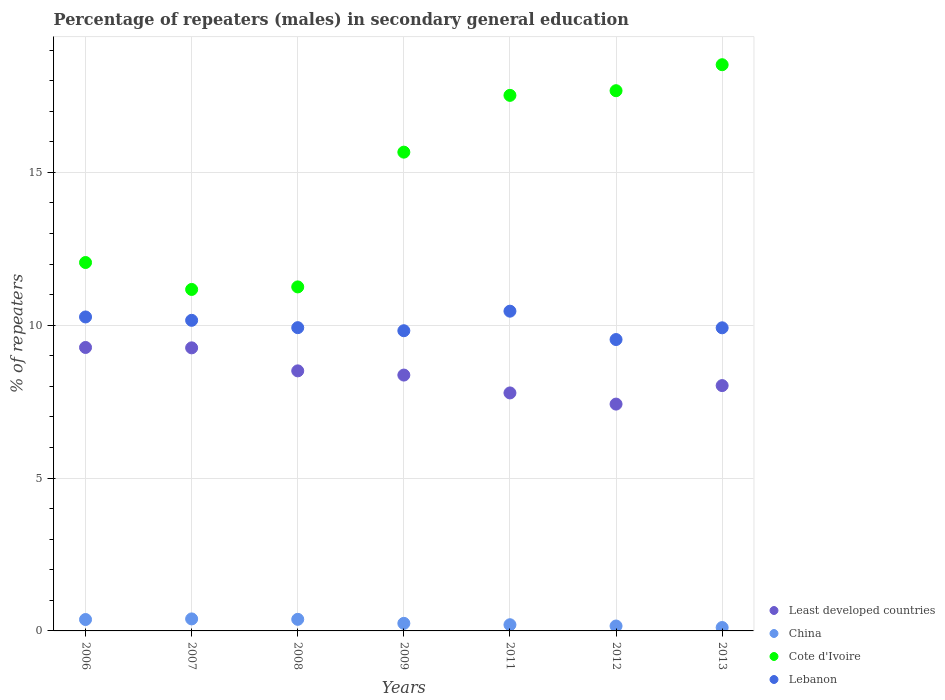What is the percentage of male repeaters in Least developed countries in 2006?
Give a very brief answer. 9.27. Across all years, what is the maximum percentage of male repeaters in Lebanon?
Give a very brief answer. 10.46. Across all years, what is the minimum percentage of male repeaters in China?
Make the answer very short. 0.11. In which year was the percentage of male repeaters in Lebanon maximum?
Keep it short and to the point. 2011. What is the total percentage of male repeaters in China in the graph?
Provide a short and direct response. 1.87. What is the difference between the percentage of male repeaters in Cote d'Ivoire in 2008 and that in 2013?
Provide a succinct answer. -7.27. What is the difference between the percentage of male repeaters in Lebanon in 2006 and the percentage of male repeaters in China in 2013?
Provide a succinct answer. 10.16. What is the average percentage of male repeaters in China per year?
Keep it short and to the point. 0.27. In the year 2011, what is the difference between the percentage of male repeaters in Lebanon and percentage of male repeaters in China?
Provide a short and direct response. 10.26. What is the ratio of the percentage of male repeaters in Cote d'Ivoire in 2008 to that in 2013?
Your answer should be very brief. 0.61. Is the difference between the percentage of male repeaters in Lebanon in 2009 and 2012 greater than the difference between the percentage of male repeaters in China in 2009 and 2012?
Give a very brief answer. Yes. What is the difference between the highest and the second highest percentage of male repeaters in Cote d'Ivoire?
Provide a succinct answer. 0.85. What is the difference between the highest and the lowest percentage of male repeaters in Lebanon?
Your response must be concise. 0.93. Is the sum of the percentage of male repeaters in Lebanon in 2008 and 2012 greater than the maximum percentage of male repeaters in Cote d'Ivoire across all years?
Your answer should be very brief. Yes. Does the percentage of male repeaters in Lebanon monotonically increase over the years?
Give a very brief answer. No. Is the percentage of male repeaters in Least developed countries strictly less than the percentage of male repeaters in Lebanon over the years?
Keep it short and to the point. Yes. How many dotlines are there?
Your answer should be very brief. 4. How many years are there in the graph?
Your response must be concise. 7. Does the graph contain any zero values?
Provide a succinct answer. No. Where does the legend appear in the graph?
Offer a terse response. Bottom right. How many legend labels are there?
Offer a terse response. 4. How are the legend labels stacked?
Give a very brief answer. Vertical. What is the title of the graph?
Ensure brevity in your answer.  Percentage of repeaters (males) in secondary general education. What is the label or title of the X-axis?
Make the answer very short. Years. What is the label or title of the Y-axis?
Your answer should be very brief. % of repeaters. What is the % of repeaters in Least developed countries in 2006?
Offer a very short reply. 9.27. What is the % of repeaters of China in 2006?
Your answer should be compact. 0.37. What is the % of repeaters of Cote d'Ivoire in 2006?
Give a very brief answer. 12.05. What is the % of repeaters in Lebanon in 2006?
Keep it short and to the point. 10.27. What is the % of repeaters in Least developed countries in 2007?
Provide a succinct answer. 9.26. What is the % of repeaters of China in 2007?
Ensure brevity in your answer.  0.39. What is the % of repeaters of Cote d'Ivoire in 2007?
Your answer should be very brief. 11.17. What is the % of repeaters in Lebanon in 2007?
Your response must be concise. 10.16. What is the % of repeaters of Least developed countries in 2008?
Provide a succinct answer. 8.51. What is the % of repeaters in China in 2008?
Your answer should be compact. 0.38. What is the % of repeaters of Cote d'Ivoire in 2008?
Your answer should be compact. 11.25. What is the % of repeaters in Lebanon in 2008?
Offer a very short reply. 9.92. What is the % of repeaters of Least developed countries in 2009?
Your answer should be compact. 8.37. What is the % of repeaters in China in 2009?
Offer a very short reply. 0.25. What is the % of repeaters in Cote d'Ivoire in 2009?
Give a very brief answer. 15.66. What is the % of repeaters of Lebanon in 2009?
Provide a succinct answer. 9.82. What is the % of repeaters in Least developed countries in 2011?
Your response must be concise. 7.78. What is the % of repeaters in China in 2011?
Keep it short and to the point. 0.2. What is the % of repeaters of Cote d'Ivoire in 2011?
Keep it short and to the point. 17.52. What is the % of repeaters of Lebanon in 2011?
Offer a very short reply. 10.46. What is the % of repeaters in Least developed countries in 2012?
Your answer should be compact. 7.42. What is the % of repeaters in China in 2012?
Provide a succinct answer. 0.16. What is the % of repeaters in Cote d'Ivoire in 2012?
Ensure brevity in your answer.  17.67. What is the % of repeaters in Lebanon in 2012?
Offer a terse response. 9.53. What is the % of repeaters of Least developed countries in 2013?
Make the answer very short. 8.02. What is the % of repeaters of China in 2013?
Give a very brief answer. 0.11. What is the % of repeaters in Cote d'Ivoire in 2013?
Offer a terse response. 18.52. What is the % of repeaters of Lebanon in 2013?
Offer a very short reply. 9.91. Across all years, what is the maximum % of repeaters of Least developed countries?
Ensure brevity in your answer.  9.27. Across all years, what is the maximum % of repeaters in China?
Your response must be concise. 0.39. Across all years, what is the maximum % of repeaters in Cote d'Ivoire?
Your answer should be very brief. 18.52. Across all years, what is the maximum % of repeaters in Lebanon?
Your answer should be very brief. 10.46. Across all years, what is the minimum % of repeaters of Least developed countries?
Your response must be concise. 7.42. Across all years, what is the minimum % of repeaters of China?
Provide a short and direct response. 0.11. Across all years, what is the minimum % of repeaters of Cote d'Ivoire?
Your response must be concise. 11.17. Across all years, what is the minimum % of repeaters of Lebanon?
Provide a short and direct response. 9.53. What is the total % of repeaters in Least developed countries in the graph?
Make the answer very short. 58.63. What is the total % of repeaters of China in the graph?
Ensure brevity in your answer.  1.87. What is the total % of repeaters in Cote d'Ivoire in the graph?
Your answer should be compact. 103.84. What is the total % of repeaters in Lebanon in the graph?
Provide a short and direct response. 70.07. What is the difference between the % of repeaters of Least developed countries in 2006 and that in 2007?
Ensure brevity in your answer.  0.01. What is the difference between the % of repeaters in China in 2006 and that in 2007?
Provide a succinct answer. -0.02. What is the difference between the % of repeaters of Cote d'Ivoire in 2006 and that in 2007?
Keep it short and to the point. 0.88. What is the difference between the % of repeaters in Lebanon in 2006 and that in 2007?
Keep it short and to the point. 0.11. What is the difference between the % of repeaters of Least developed countries in 2006 and that in 2008?
Offer a very short reply. 0.77. What is the difference between the % of repeaters of China in 2006 and that in 2008?
Your response must be concise. -0.01. What is the difference between the % of repeaters of Cote d'Ivoire in 2006 and that in 2008?
Your answer should be compact. 0.8. What is the difference between the % of repeaters of Lebanon in 2006 and that in 2008?
Your answer should be very brief. 0.35. What is the difference between the % of repeaters of Least developed countries in 2006 and that in 2009?
Your response must be concise. 0.9. What is the difference between the % of repeaters of China in 2006 and that in 2009?
Your response must be concise. 0.13. What is the difference between the % of repeaters in Cote d'Ivoire in 2006 and that in 2009?
Ensure brevity in your answer.  -3.61. What is the difference between the % of repeaters in Lebanon in 2006 and that in 2009?
Provide a short and direct response. 0.45. What is the difference between the % of repeaters of Least developed countries in 2006 and that in 2011?
Provide a short and direct response. 1.49. What is the difference between the % of repeaters in China in 2006 and that in 2011?
Give a very brief answer. 0.17. What is the difference between the % of repeaters in Cote d'Ivoire in 2006 and that in 2011?
Provide a short and direct response. -5.47. What is the difference between the % of repeaters of Lebanon in 2006 and that in 2011?
Ensure brevity in your answer.  -0.19. What is the difference between the % of repeaters in Least developed countries in 2006 and that in 2012?
Offer a terse response. 1.85. What is the difference between the % of repeaters of China in 2006 and that in 2012?
Provide a succinct answer. 0.21. What is the difference between the % of repeaters in Cote d'Ivoire in 2006 and that in 2012?
Provide a short and direct response. -5.62. What is the difference between the % of repeaters in Lebanon in 2006 and that in 2012?
Provide a short and direct response. 0.74. What is the difference between the % of repeaters in Least developed countries in 2006 and that in 2013?
Provide a succinct answer. 1.25. What is the difference between the % of repeaters in China in 2006 and that in 2013?
Offer a terse response. 0.26. What is the difference between the % of repeaters of Cote d'Ivoire in 2006 and that in 2013?
Your answer should be very brief. -6.47. What is the difference between the % of repeaters in Lebanon in 2006 and that in 2013?
Keep it short and to the point. 0.35. What is the difference between the % of repeaters of Least developed countries in 2007 and that in 2008?
Make the answer very short. 0.75. What is the difference between the % of repeaters of China in 2007 and that in 2008?
Provide a short and direct response. 0.01. What is the difference between the % of repeaters in Cote d'Ivoire in 2007 and that in 2008?
Offer a very short reply. -0.08. What is the difference between the % of repeaters of Lebanon in 2007 and that in 2008?
Your response must be concise. 0.24. What is the difference between the % of repeaters of Least developed countries in 2007 and that in 2009?
Your response must be concise. 0.89. What is the difference between the % of repeaters of China in 2007 and that in 2009?
Your answer should be very brief. 0.14. What is the difference between the % of repeaters of Cote d'Ivoire in 2007 and that in 2009?
Ensure brevity in your answer.  -4.49. What is the difference between the % of repeaters in Lebanon in 2007 and that in 2009?
Offer a terse response. 0.34. What is the difference between the % of repeaters of Least developed countries in 2007 and that in 2011?
Provide a succinct answer. 1.47. What is the difference between the % of repeaters in China in 2007 and that in 2011?
Your answer should be very brief. 0.19. What is the difference between the % of repeaters of Cote d'Ivoire in 2007 and that in 2011?
Provide a succinct answer. -6.35. What is the difference between the % of repeaters in Lebanon in 2007 and that in 2011?
Offer a terse response. -0.3. What is the difference between the % of repeaters of Least developed countries in 2007 and that in 2012?
Keep it short and to the point. 1.84. What is the difference between the % of repeaters of China in 2007 and that in 2012?
Your answer should be very brief. 0.23. What is the difference between the % of repeaters of Cote d'Ivoire in 2007 and that in 2012?
Offer a terse response. -6.5. What is the difference between the % of repeaters of Lebanon in 2007 and that in 2012?
Offer a very short reply. 0.63. What is the difference between the % of repeaters of Least developed countries in 2007 and that in 2013?
Your answer should be compact. 1.23. What is the difference between the % of repeaters in China in 2007 and that in 2013?
Keep it short and to the point. 0.28. What is the difference between the % of repeaters in Cote d'Ivoire in 2007 and that in 2013?
Provide a succinct answer. -7.35. What is the difference between the % of repeaters in Lebanon in 2007 and that in 2013?
Make the answer very short. 0.24. What is the difference between the % of repeaters of Least developed countries in 2008 and that in 2009?
Your answer should be very brief. 0.14. What is the difference between the % of repeaters of China in 2008 and that in 2009?
Provide a short and direct response. 0.13. What is the difference between the % of repeaters of Cote d'Ivoire in 2008 and that in 2009?
Keep it short and to the point. -4.41. What is the difference between the % of repeaters of Lebanon in 2008 and that in 2009?
Your answer should be compact. 0.1. What is the difference between the % of repeaters in Least developed countries in 2008 and that in 2011?
Provide a succinct answer. 0.72. What is the difference between the % of repeaters of China in 2008 and that in 2011?
Your answer should be very brief. 0.18. What is the difference between the % of repeaters of Cote d'Ivoire in 2008 and that in 2011?
Provide a short and direct response. -6.27. What is the difference between the % of repeaters in Lebanon in 2008 and that in 2011?
Offer a terse response. -0.54. What is the difference between the % of repeaters in Least developed countries in 2008 and that in 2012?
Offer a very short reply. 1.09. What is the difference between the % of repeaters of China in 2008 and that in 2012?
Give a very brief answer. 0.22. What is the difference between the % of repeaters in Cote d'Ivoire in 2008 and that in 2012?
Provide a succinct answer. -6.42. What is the difference between the % of repeaters of Lebanon in 2008 and that in 2012?
Ensure brevity in your answer.  0.39. What is the difference between the % of repeaters in Least developed countries in 2008 and that in 2013?
Your response must be concise. 0.48. What is the difference between the % of repeaters in China in 2008 and that in 2013?
Ensure brevity in your answer.  0.27. What is the difference between the % of repeaters of Cote d'Ivoire in 2008 and that in 2013?
Offer a very short reply. -7.27. What is the difference between the % of repeaters of Lebanon in 2008 and that in 2013?
Ensure brevity in your answer.  0. What is the difference between the % of repeaters in Least developed countries in 2009 and that in 2011?
Give a very brief answer. 0.58. What is the difference between the % of repeaters of China in 2009 and that in 2011?
Provide a succinct answer. 0.05. What is the difference between the % of repeaters of Cote d'Ivoire in 2009 and that in 2011?
Keep it short and to the point. -1.86. What is the difference between the % of repeaters of Lebanon in 2009 and that in 2011?
Offer a very short reply. -0.64. What is the difference between the % of repeaters of Least developed countries in 2009 and that in 2012?
Your response must be concise. 0.95. What is the difference between the % of repeaters of China in 2009 and that in 2012?
Your response must be concise. 0.09. What is the difference between the % of repeaters in Cote d'Ivoire in 2009 and that in 2012?
Ensure brevity in your answer.  -2.01. What is the difference between the % of repeaters of Lebanon in 2009 and that in 2012?
Ensure brevity in your answer.  0.29. What is the difference between the % of repeaters of Least developed countries in 2009 and that in 2013?
Your answer should be very brief. 0.34. What is the difference between the % of repeaters of China in 2009 and that in 2013?
Your response must be concise. 0.14. What is the difference between the % of repeaters of Cote d'Ivoire in 2009 and that in 2013?
Keep it short and to the point. -2.86. What is the difference between the % of repeaters of Lebanon in 2009 and that in 2013?
Provide a succinct answer. -0.1. What is the difference between the % of repeaters in Least developed countries in 2011 and that in 2012?
Your response must be concise. 0.37. What is the difference between the % of repeaters of China in 2011 and that in 2012?
Your answer should be very brief. 0.04. What is the difference between the % of repeaters of Cote d'Ivoire in 2011 and that in 2012?
Provide a short and direct response. -0.15. What is the difference between the % of repeaters in Lebanon in 2011 and that in 2012?
Give a very brief answer. 0.93. What is the difference between the % of repeaters in Least developed countries in 2011 and that in 2013?
Your response must be concise. -0.24. What is the difference between the % of repeaters in China in 2011 and that in 2013?
Your answer should be compact. 0.09. What is the difference between the % of repeaters in Cote d'Ivoire in 2011 and that in 2013?
Your answer should be very brief. -1. What is the difference between the % of repeaters of Lebanon in 2011 and that in 2013?
Offer a very short reply. 0.54. What is the difference between the % of repeaters in Least developed countries in 2012 and that in 2013?
Offer a terse response. -0.61. What is the difference between the % of repeaters in China in 2012 and that in 2013?
Offer a terse response. 0.05. What is the difference between the % of repeaters in Cote d'Ivoire in 2012 and that in 2013?
Make the answer very short. -0.85. What is the difference between the % of repeaters in Lebanon in 2012 and that in 2013?
Offer a terse response. -0.38. What is the difference between the % of repeaters in Least developed countries in 2006 and the % of repeaters in China in 2007?
Offer a terse response. 8.88. What is the difference between the % of repeaters of Least developed countries in 2006 and the % of repeaters of Cote d'Ivoire in 2007?
Your response must be concise. -1.9. What is the difference between the % of repeaters of Least developed countries in 2006 and the % of repeaters of Lebanon in 2007?
Offer a terse response. -0.89. What is the difference between the % of repeaters in China in 2006 and the % of repeaters in Cote d'Ivoire in 2007?
Offer a terse response. -10.8. What is the difference between the % of repeaters in China in 2006 and the % of repeaters in Lebanon in 2007?
Your answer should be very brief. -9.79. What is the difference between the % of repeaters of Cote d'Ivoire in 2006 and the % of repeaters of Lebanon in 2007?
Give a very brief answer. 1.89. What is the difference between the % of repeaters in Least developed countries in 2006 and the % of repeaters in China in 2008?
Keep it short and to the point. 8.89. What is the difference between the % of repeaters in Least developed countries in 2006 and the % of repeaters in Cote d'Ivoire in 2008?
Make the answer very short. -1.98. What is the difference between the % of repeaters in Least developed countries in 2006 and the % of repeaters in Lebanon in 2008?
Give a very brief answer. -0.65. What is the difference between the % of repeaters in China in 2006 and the % of repeaters in Cote d'Ivoire in 2008?
Offer a very short reply. -10.88. What is the difference between the % of repeaters of China in 2006 and the % of repeaters of Lebanon in 2008?
Keep it short and to the point. -9.55. What is the difference between the % of repeaters of Cote d'Ivoire in 2006 and the % of repeaters of Lebanon in 2008?
Offer a terse response. 2.13. What is the difference between the % of repeaters in Least developed countries in 2006 and the % of repeaters in China in 2009?
Your answer should be compact. 9.02. What is the difference between the % of repeaters in Least developed countries in 2006 and the % of repeaters in Cote d'Ivoire in 2009?
Provide a short and direct response. -6.39. What is the difference between the % of repeaters of Least developed countries in 2006 and the % of repeaters of Lebanon in 2009?
Your answer should be compact. -0.55. What is the difference between the % of repeaters in China in 2006 and the % of repeaters in Cote d'Ivoire in 2009?
Ensure brevity in your answer.  -15.29. What is the difference between the % of repeaters of China in 2006 and the % of repeaters of Lebanon in 2009?
Keep it short and to the point. -9.45. What is the difference between the % of repeaters of Cote d'Ivoire in 2006 and the % of repeaters of Lebanon in 2009?
Give a very brief answer. 2.23. What is the difference between the % of repeaters of Least developed countries in 2006 and the % of repeaters of China in 2011?
Make the answer very short. 9.07. What is the difference between the % of repeaters in Least developed countries in 2006 and the % of repeaters in Cote d'Ivoire in 2011?
Make the answer very short. -8.25. What is the difference between the % of repeaters of Least developed countries in 2006 and the % of repeaters of Lebanon in 2011?
Provide a short and direct response. -1.19. What is the difference between the % of repeaters in China in 2006 and the % of repeaters in Cote d'Ivoire in 2011?
Your response must be concise. -17.14. What is the difference between the % of repeaters in China in 2006 and the % of repeaters in Lebanon in 2011?
Offer a very short reply. -10.09. What is the difference between the % of repeaters in Cote d'Ivoire in 2006 and the % of repeaters in Lebanon in 2011?
Provide a short and direct response. 1.59. What is the difference between the % of repeaters of Least developed countries in 2006 and the % of repeaters of China in 2012?
Provide a succinct answer. 9.11. What is the difference between the % of repeaters of Least developed countries in 2006 and the % of repeaters of Cote d'Ivoire in 2012?
Ensure brevity in your answer.  -8.4. What is the difference between the % of repeaters of Least developed countries in 2006 and the % of repeaters of Lebanon in 2012?
Offer a very short reply. -0.26. What is the difference between the % of repeaters of China in 2006 and the % of repeaters of Cote d'Ivoire in 2012?
Your answer should be very brief. -17.3. What is the difference between the % of repeaters in China in 2006 and the % of repeaters in Lebanon in 2012?
Ensure brevity in your answer.  -9.16. What is the difference between the % of repeaters of Cote d'Ivoire in 2006 and the % of repeaters of Lebanon in 2012?
Your answer should be very brief. 2.52. What is the difference between the % of repeaters in Least developed countries in 2006 and the % of repeaters in China in 2013?
Offer a terse response. 9.16. What is the difference between the % of repeaters in Least developed countries in 2006 and the % of repeaters in Cote d'Ivoire in 2013?
Make the answer very short. -9.25. What is the difference between the % of repeaters in Least developed countries in 2006 and the % of repeaters in Lebanon in 2013?
Provide a short and direct response. -0.64. What is the difference between the % of repeaters in China in 2006 and the % of repeaters in Cote d'Ivoire in 2013?
Offer a very short reply. -18.15. What is the difference between the % of repeaters in China in 2006 and the % of repeaters in Lebanon in 2013?
Provide a succinct answer. -9.54. What is the difference between the % of repeaters of Cote d'Ivoire in 2006 and the % of repeaters of Lebanon in 2013?
Your answer should be very brief. 2.14. What is the difference between the % of repeaters of Least developed countries in 2007 and the % of repeaters of China in 2008?
Provide a succinct answer. 8.88. What is the difference between the % of repeaters in Least developed countries in 2007 and the % of repeaters in Cote d'Ivoire in 2008?
Your response must be concise. -1.99. What is the difference between the % of repeaters of Least developed countries in 2007 and the % of repeaters of Lebanon in 2008?
Ensure brevity in your answer.  -0.66. What is the difference between the % of repeaters in China in 2007 and the % of repeaters in Cote d'Ivoire in 2008?
Offer a very short reply. -10.86. What is the difference between the % of repeaters of China in 2007 and the % of repeaters of Lebanon in 2008?
Keep it short and to the point. -9.53. What is the difference between the % of repeaters of Cote d'Ivoire in 2007 and the % of repeaters of Lebanon in 2008?
Your answer should be very brief. 1.25. What is the difference between the % of repeaters of Least developed countries in 2007 and the % of repeaters of China in 2009?
Your answer should be very brief. 9.01. What is the difference between the % of repeaters of Least developed countries in 2007 and the % of repeaters of Cote d'Ivoire in 2009?
Your answer should be compact. -6.4. What is the difference between the % of repeaters of Least developed countries in 2007 and the % of repeaters of Lebanon in 2009?
Your answer should be compact. -0.56. What is the difference between the % of repeaters of China in 2007 and the % of repeaters of Cote d'Ivoire in 2009?
Your response must be concise. -15.27. What is the difference between the % of repeaters in China in 2007 and the % of repeaters in Lebanon in 2009?
Your answer should be compact. -9.43. What is the difference between the % of repeaters of Cote d'Ivoire in 2007 and the % of repeaters of Lebanon in 2009?
Keep it short and to the point. 1.35. What is the difference between the % of repeaters in Least developed countries in 2007 and the % of repeaters in China in 2011?
Give a very brief answer. 9.06. What is the difference between the % of repeaters in Least developed countries in 2007 and the % of repeaters in Cote d'Ivoire in 2011?
Keep it short and to the point. -8.26. What is the difference between the % of repeaters of Least developed countries in 2007 and the % of repeaters of Lebanon in 2011?
Ensure brevity in your answer.  -1.2. What is the difference between the % of repeaters of China in 2007 and the % of repeaters of Cote d'Ivoire in 2011?
Give a very brief answer. -17.12. What is the difference between the % of repeaters of China in 2007 and the % of repeaters of Lebanon in 2011?
Keep it short and to the point. -10.07. What is the difference between the % of repeaters in Cote d'Ivoire in 2007 and the % of repeaters in Lebanon in 2011?
Ensure brevity in your answer.  0.71. What is the difference between the % of repeaters of Least developed countries in 2007 and the % of repeaters of China in 2012?
Ensure brevity in your answer.  9.1. What is the difference between the % of repeaters in Least developed countries in 2007 and the % of repeaters in Cote d'Ivoire in 2012?
Your answer should be very brief. -8.41. What is the difference between the % of repeaters of Least developed countries in 2007 and the % of repeaters of Lebanon in 2012?
Offer a terse response. -0.27. What is the difference between the % of repeaters of China in 2007 and the % of repeaters of Cote d'Ivoire in 2012?
Your answer should be very brief. -17.28. What is the difference between the % of repeaters in China in 2007 and the % of repeaters in Lebanon in 2012?
Provide a short and direct response. -9.14. What is the difference between the % of repeaters in Cote d'Ivoire in 2007 and the % of repeaters in Lebanon in 2012?
Ensure brevity in your answer.  1.64. What is the difference between the % of repeaters in Least developed countries in 2007 and the % of repeaters in China in 2013?
Give a very brief answer. 9.15. What is the difference between the % of repeaters in Least developed countries in 2007 and the % of repeaters in Cote d'Ivoire in 2013?
Offer a terse response. -9.26. What is the difference between the % of repeaters of Least developed countries in 2007 and the % of repeaters of Lebanon in 2013?
Offer a very short reply. -0.66. What is the difference between the % of repeaters in China in 2007 and the % of repeaters in Cote d'Ivoire in 2013?
Your answer should be compact. -18.13. What is the difference between the % of repeaters in China in 2007 and the % of repeaters in Lebanon in 2013?
Provide a short and direct response. -9.52. What is the difference between the % of repeaters in Cote d'Ivoire in 2007 and the % of repeaters in Lebanon in 2013?
Provide a short and direct response. 1.25. What is the difference between the % of repeaters in Least developed countries in 2008 and the % of repeaters in China in 2009?
Your answer should be compact. 8.26. What is the difference between the % of repeaters in Least developed countries in 2008 and the % of repeaters in Cote d'Ivoire in 2009?
Your answer should be very brief. -7.15. What is the difference between the % of repeaters in Least developed countries in 2008 and the % of repeaters in Lebanon in 2009?
Keep it short and to the point. -1.31. What is the difference between the % of repeaters in China in 2008 and the % of repeaters in Cote d'Ivoire in 2009?
Provide a short and direct response. -15.28. What is the difference between the % of repeaters in China in 2008 and the % of repeaters in Lebanon in 2009?
Provide a succinct answer. -9.44. What is the difference between the % of repeaters in Cote d'Ivoire in 2008 and the % of repeaters in Lebanon in 2009?
Provide a short and direct response. 1.43. What is the difference between the % of repeaters of Least developed countries in 2008 and the % of repeaters of China in 2011?
Provide a succinct answer. 8.3. What is the difference between the % of repeaters in Least developed countries in 2008 and the % of repeaters in Cote d'Ivoire in 2011?
Keep it short and to the point. -9.01. What is the difference between the % of repeaters of Least developed countries in 2008 and the % of repeaters of Lebanon in 2011?
Offer a very short reply. -1.95. What is the difference between the % of repeaters in China in 2008 and the % of repeaters in Cote d'Ivoire in 2011?
Give a very brief answer. -17.14. What is the difference between the % of repeaters in China in 2008 and the % of repeaters in Lebanon in 2011?
Give a very brief answer. -10.08. What is the difference between the % of repeaters of Cote d'Ivoire in 2008 and the % of repeaters of Lebanon in 2011?
Your answer should be compact. 0.79. What is the difference between the % of repeaters of Least developed countries in 2008 and the % of repeaters of China in 2012?
Provide a short and direct response. 8.35. What is the difference between the % of repeaters in Least developed countries in 2008 and the % of repeaters in Cote d'Ivoire in 2012?
Keep it short and to the point. -9.16. What is the difference between the % of repeaters in Least developed countries in 2008 and the % of repeaters in Lebanon in 2012?
Keep it short and to the point. -1.02. What is the difference between the % of repeaters of China in 2008 and the % of repeaters of Cote d'Ivoire in 2012?
Give a very brief answer. -17.29. What is the difference between the % of repeaters of China in 2008 and the % of repeaters of Lebanon in 2012?
Your response must be concise. -9.15. What is the difference between the % of repeaters of Cote d'Ivoire in 2008 and the % of repeaters of Lebanon in 2012?
Make the answer very short. 1.72. What is the difference between the % of repeaters of Least developed countries in 2008 and the % of repeaters of China in 2013?
Your response must be concise. 8.4. What is the difference between the % of repeaters in Least developed countries in 2008 and the % of repeaters in Cote d'Ivoire in 2013?
Your answer should be very brief. -10.01. What is the difference between the % of repeaters in Least developed countries in 2008 and the % of repeaters in Lebanon in 2013?
Offer a very short reply. -1.41. What is the difference between the % of repeaters of China in 2008 and the % of repeaters of Cote d'Ivoire in 2013?
Provide a short and direct response. -18.14. What is the difference between the % of repeaters of China in 2008 and the % of repeaters of Lebanon in 2013?
Your answer should be compact. -9.54. What is the difference between the % of repeaters of Cote d'Ivoire in 2008 and the % of repeaters of Lebanon in 2013?
Provide a succinct answer. 1.34. What is the difference between the % of repeaters in Least developed countries in 2009 and the % of repeaters in China in 2011?
Keep it short and to the point. 8.17. What is the difference between the % of repeaters of Least developed countries in 2009 and the % of repeaters of Cote d'Ivoire in 2011?
Your response must be concise. -9.15. What is the difference between the % of repeaters of Least developed countries in 2009 and the % of repeaters of Lebanon in 2011?
Provide a short and direct response. -2.09. What is the difference between the % of repeaters of China in 2009 and the % of repeaters of Cote d'Ivoire in 2011?
Keep it short and to the point. -17.27. What is the difference between the % of repeaters in China in 2009 and the % of repeaters in Lebanon in 2011?
Offer a terse response. -10.21. What is the difference between the % of repeaters of Cote d'Ivoire in 2009 and the % of repeaters of Lebanon in 2011?
Give a very brief answer. 5.2. What is the difference between the % of repeaters in Least developed countries in 2009 and the % of repeaters in China in 2012?
Give a very brief answer. 8.21. What is the difference between the % of repeaters in Least developed countries in 2009 and the % of repeaters in Cote d'Ivoire in 2012?
Your answer should be very brief. -9.3. What is the difference between the % of repeaters in Least developed countries in 2009 and the % of repeaters in Lebanon in 2012?
Your answer should be very brief. -1.16. What is the difference between the % of repeaters in China in 2009 and the % of repeaters in Cote d'Ivoire in 2012?
Provide a succinct answer. -17.42. What is the difference between the % of repeaters of China in 2009 and the % of repeaters of Lebanon in 2012?
Provide a succinct answer. -9.28. What is the difference between the % of repeaters in Cote d'Ivoire in 2009 and the % of repeaters in Lebanon in 2012?
Your response must be concise. 6.13. What is the difference between the % of repeaters in Least developed countries in 2009 and the % of repeaters in China in 2013?
Provide a succinct answer. 8.26. What is the difference between the % of repeaters in Least developed countries in 2009 and the % of repeaters in Cote d'Ivoire in 2013?
Offer a terse response. -10.15. What is the difference between the % of repeaters in Least developed countries in 2009 and the % of repeaters in Lebanon in 2013?
Your answer should be very brief. -1.55. What is the difference between the % of repeaters of China in 2009 and the % of repeaters of Cote d'Ivoire in 2013?
Your answer should be very brief. -18.27. What is the difference between the % of repeaters in China in 2009 and the % of repeaters in Lebanon in 2013?
Your answer should be compact. -9.67. What is the difference between the % of repeaters in Cote d'Ivoire in 2009 and the % of repeaters in Lebanon in 2013?
Offer a very short reply. 5.75. What is the difference between the % of repeaters in Least developed countries in 2011 and the % of repeaters in China in 2012?
Offer a very short reply. 7.62. What is the difference between the % of repeaters in Least developed countries in 2011 and the % of repeaters in Cote d'Ivoire in 2012?
Make the answer very short. -9.89. What is the difference between the % of repeaters in Least developed countries in 2011 and the % of repeaters in Lebanon in 2012?
Your answer should be very brief. -1.75. What is the difference between the % of repeaters of China in 2011 and the % of repeaters of Cote d'Ivoire in 2012?
Your response must be concise. -17.47. What is the difference between the % of repeaters of China in 2011 and the % of repeaters of Lebanon in 2012?
Ensure brevity in your answer.  -9.33. What is the difference between the % of repeaters of Cote d'Ivoire in 2011 and the % of repeaters of Lebanon in 2012?
Ensure brevity in your answer.  7.99. What is the difference between the % of repeaters in Least developed countries in 2011 and the % of repeaters in China in 2013?
Give a very brief answer. 7.67. What is the difference between the % of repeaters of Least developed countries in 2011 and the % of repeaters of Cote d'Ivoire in 2013?
Ensure brevity in your answer.  -10.74. What is the difference between the % of repeaters in Least developed countries in 2011 and the % of repeaters in Lebanon in 2013?
Provide a succinct answer. -2.13. What is the difference between the % of repeaters of China in 2011 and the % of repeaters of Cote d'Ivoire in 2013?
Keep it short and to the point. -18.32. What is the difference between the % of repeaters of China in 2011 and the % of repeaters of Lebanon in 2013?
Offer a very short reply. -9.71. What is the difference between the % of repeaters of Cote d'Ivoire in 2011 and the % of repeaters of Lebanon in 2013?
Keep it short and to the point. 7.6. What is the difference between the % of repeaters in Least developed countries in 2012 and the % of repeaters in China in 2013?
Keep it short and to the point. 7.31. What is the difference between the % of repeaters in Least developed countries in 2012 and the % of repeaters in Cote d'Ivoire in 2013?
Provide a succinct answer. -11.1. What is the difference between the % of repeaters of Least developed countries in 2012 and the % of repeaters of Lebanon in 2013?
Ensure brevity in your answer.  -2.5. What is the difference between the % of repeaters in China in 2012 and the % of repeaters in Cote d'Ivoire in 2013?
Offer a very short reply. -18.36. What is the difference between the % of repeaters of China in 2012 and the % of repeaters of Lebanon in 2013?
Offer a very short reply. -9.75. What is the difference between the % of repeaters of Cote d'Ivoire in 2012 and the % of repeaters of Lebanon in 2013?
Your answer should be compact. 7.76. What is the average % of repeaters of Least developed countries per year?
Keep it short and to the point. 8.38. What is the average % of repeaters of China per year?
Provide a succinct answer. 0.27. What is the average % of repeaters of Cote d'Ivoire per year?
Keep it short and to the point. 14.83. What is the average % of repeaters of Lebanon per year?
Offer a terse response. 10.01. In the year 2006, what is the difference between the % of repeaters of Least developed countries and % of repeaters of China?
Your response must be concise. 8.9. In the year 2006, what is the difference between the % of repeaters of Least developed countries and % of repeaters of Cote d'Ivoire?
Provide a short and direct response. -2.78. In the year 2006, what is the difference between the % of repeaters in Least developed countries and % of repeaters in Lebanon?
Your answer should be very brief. -1. In the year 2006, what is the difference between the % of repeaters in China and % of repeaters in Cote d'Ivoire?
Offer a terse response. -11.68. In the year 2006, what is the difference between the % of repeaters in China and % of repeaters in Lebanon?
Provide a short and direct response. -9.9. In the year 2006, what is the difference between the % of repeaters in Cote d'Ivoire and % of repeaters in Lebanon?
Provide a short and direct response. 1.78. In the year 2007, what is the difference between the % of repeaters of Least developed countries and % of repeaters of China?
Offer a terse response. 8.87. In the year 2007, what is the difference between the % of repeaters in Least developed countries and % of repeaters in Cote d'Ivoire?
Your answer should be compact. -1.91. In the year 2007, what is the difference between the % of repeaters in Least developed countries and % of repeaters in Lebanon?
Offer a terse response. -0.9. In the year 2007, what is the difference between the % of repeaters of China and % of repeaters of Cote d'Ivoire?
Provide a succinct answer. -10.78. In the year 2007, what is the difference between the % of repeaters in China and % of repeaters in Lebanon?
Offer a terse response. -9.77. In the year 2007, what is the difference between the % of repeaters of Cote d'Ivoire and % of repeaters of Lebanon?
Provide a short and direct response. 1.01. In the year 2008, what is the difference between the % of repeaters in Least developed countries and % of repeaters in China?
Your answer should be compact. 8.13. In the year 2008, what is the difference between the % of repeaters of Least developed countries and % of repeaters of Cote d'Ivoire?
Give a very brief answer. -2.75. In the year 2008, what is the difference between the % of repeaters of Least developed countries and % of repeaters of Lebanon?
Make the answer very short. -1.41. In the year 2008, what is the difference between the % of repeaters of China and % of repeaters of Cote d'Ivoire?
Ensure brevity in your answer.  -10.87. In the year 2008, what is the difference between the % of repeaters of China and % of repeaters of Lebanon?
Make the answer very short. -9.54. In the year 2008, what is the difference between the % of repeaters in Cote d'Ivoire and % of repeaters in Lebanon?
Offer a terse response. 1.33. In the year 2009, what is the difference between the % of repeaters in Least developed countries and % of repeaters in China?
Make the answer very short. 8.12. In the year 2009, what is the difference between the % of repeaters of Least developed countries and % of repeaters of Cote d'Ivoire?
Give a very brief answer. -7.29. In the year 2009, what is the difference between the % of repeaters in Least developed countries and % of repeaters in Lebanon?
Ensure brevity in your answer.  -1.45. In the year 2009, what is the difference between the % of repeaters in China and % of repeaters in Cote d'Ivoire?
Your response must be concise. -15.41. In the year 2009, what is the difference between the % of repeaters of China and % of repeaters of Lebanon?
Offer a very short reply. -9.57. In the year 2009, what is the difference between the % of repeaters of Cote d'Ivoire and % of repeaters of Lebanon?
Give a very brief answer. 5.84. In the year 2011, what is the difference between the % of repeaters in Least developed countries and % of repeaters in China?
Ensure brevity in your answer.  7.58. In the year 2011, what is the difference between the % of repeaters of Least developed countries and % of repeaters of Cote d'Ivoire?
Your answer should be compact. -9.73. In the year 2011, what is the difference between the % of repeaters in Least developed countries and % of repeaters in Lebanon?
Offer a terse response. -2.67. In the year 2011, what is the difference between the % of repeaters of China and % of repeaters of Cote d'Ivoire?
Your answer should be very brief. -17.32. In the year 2011, what is the difference between the % of repeaters in China and % of repeaters in Lebanon?
Offer a terse response. -10.26. In the year 2011, what is the difference between the % of repeaters in Cote d'Ivoire and % of repeaters in Lebanon?
Offer a terse response. 7.06. In the year 2012, what is the difference between the % of repeaters in Least developed countries and % of repeaters in China?
Provide a short and direct response. 7.26. In the year 2012, what is the difference between the % of repeaters in Least developed countries and % of repeaters in Cote d'Ivoire?
Keep it short and to the point. -10.25. In the year 2012, what is the difference between the % of repeaters in Least developed countries and % of repeaters in Lebanon?
Provide a short and direct response. -2.11. In the year 2012, what is the difference between the % of repeaters of China and % of repeaters of Cote d'Ivoire?
Your answer should be compact. -17.51. In the year 2012, what is the difference between the % of repeaters of China and % of repeaters of Lebanon?
Offer a very short reply. -9.37. In the year 2012, what is the difference between the % of repeaters in Cote d'Ivoire and % of repeaters in Lebanon?
Make the answer very short. 8.14. In the year 2013, what is the difference between the % of repeaters of Least developed countries and % of repeaters of China?
Provide a short and direct response. 7.91. In the year 2013, what is the difference between the % of repeaters of Least developed countries and % of repeaters of Cote d'Ivoire?
Give a very brief answer. -10.5. In the year 2013, what is the difference between the % of repeaters in Least developed countries and % of repeaters in Lebanon?
Provide a succinct answer. -1.89. In the year 2013, what is the difference between the % of repeaters of China and % of repeaters of Cote d'Ivoire?
Make the answer very short. -18.41. In the year 2013, what is the difference between the % of repeaters in China and % of repeaters in Lebanon?
Your response must be concise. -9.8. In the year 2013, what is the difference between the % of repeaters of Cote d'Ivoire and % of repeaters of Lebanon?
Your response must be concise. 8.61. What is the ratio of the % of repeaters in Least developed countries in 2006 to that in 2007?
Give a very brief answer. 1. What is the ratio of the % of repeaters of China in 2006 to that in 2007?
Make the answer very short. 0.95. What is the ratio of the % of repeaters of Cote d'Ivoire in 2006 to that in 2007?
Provide a short and direct response. 1.08. What is the ratio of the % of repeaters of Lebanon in 2006 to that in 2007?
Offer a very short reply. 1.01. What is the ratio of the % of repeaters of Least developed countries in 2006 to that in 2008?
Make the answer very short. 1.09. What is the ratio of the % of repeaters in China in 2006 to that in 2008?
Give a very brief answer. 0.98. What is the ratio of the % of repeaters in Cote d'Ivoire in 2006 to that in 2008?
Provide a short and direct response. 1.07. What is the ratio of the % of repeaters in Lebanon in 2006 to that in 2008?
Your answer should be very brief. 1.04. What is the ratio of the % of repeaters of Least developed countries in 2006 to that in 2009?
Ensure brevity in your answer.  1.11. What is the ratio of the % of repeaters in China in 2006 to that in 2009?
Make the answer very short. 1.51. What is the ratio of the % of repeaters of Cote d'Ivoire in 2006 to that in 2009?
Make the answer very short. 0.77. What is the ratio of the % of repeaters in Lebanon in 2006 to that in 2009?
Ensure brevity in your answer.  1.05. What is the ratio of the % of repeaters in Least developed countries in 2006 to that in 2011?
Keep it short and to the point. 1.19. What is the ratio of the % of repeaters of China in 2006 to that in 2011?
Your answer should be very brief. 1.84. What is the ratio of the % of repeaters in Cote d'Ivoire in 2006 to that in 2011?
Ensure brevity in your answer.  0.69. What is the ratio of the % of repeaters in Lebanon in 2006 to that in 2011?
Give a very brief answer. 0.98. What is the ratio of the % of repeaters in Least developed countries in 2006 to that in 2012?
Give a very brief answer. 1.25. What is the ratio of the % of repeaters in China in 2006 to that in 2012?
Ensure brevity in your answer.  2.32. What is the ratio of the % of repeaters of Cote d'Ivoire in 2006 to that in 2012?
Ensure brevity in your answer.  0.68. What is the ratio of the % of repeaters in Lebanon in 2006 to that in 2012?
Your response must be concise. 1.08. What is the ratio of the % of repeaters in Least developed countries in 2006 to that in 2013?
Offer a very short reply. 1.16. What is the ratio of the % of repeaters in China in 2006 to that in 2013?
Make the answer very short. 3.36. What is the ratio of the % of repeaters of Cote d'Ivoire in 2006 to that in 2013?
Offer a very short reply. 0.65. What is the ratio of the % of repeaters in Lebanon in 2006 to that in 2013?
Provide a short and direct response. 1.04. What is the ratio of the % of repeaters of Least developed countries in 2007 to that in 2008?
Offer a very short reply. 1.09. What is the ratio of the % of repeaters in China in 2007 to that in 2008?
Provide a succinct answer. 1.04. What is the ratio of the % of repeaters of Lebanon in 2007 to that in 2008?
Offer a very short reply. 1.02. What is the ratio of the % of repeaters of Least developed countries in 2007 to that in 2009?
Your response must be concise. 1.11. What is the ratio of the % of repeaters of China in 2007 to that in 2009?
Keep it short and to the point. 1.59. What is the ratio of the % of repeaters in Cote d'Ivoire in 2007 to that in 2009?
Keep it short and to the point. 0.71. What is the ratio of the % of repeaters of Lebanon in 2007 to that in 2009?
Make the answer very short. 1.03. What is the ratio of the % of repeaters in Least developed countries in 2007 to that in 2011?
Offer a terse response. 1.19. What is the ratio of the % of repeaters of China in 2007 to that in 2011?
Keep it short and to the point. 1.94. What is the ratio of the % of repeaters of Cote d'Ivoire in 2007 to that in 2011?
Offer a very short reply. 0.64. What is the ratio of the % of repeaters of Lebanon in 2007 to that in 2011?
Your answer should be very brief. 0.97. What is the ratio of the % of repeaters of Least developed countries in 2007 to that in 2012?
Give a very brief answer. 1.25. What is the ratio of the % of repeaters in China in 2007 to that in 2012?
Provide a succinct answer. 2.44. What is the ratio of the % of repeaters of Cote d'Ivoire in 2007 to that in 2012?
Keep it short and to the point. 0.63. What is the ratio of the % of repeaters of Lebanon in 2007 to that in 2012?
Your answer should be very brief. 1.07. What is the ratio of the % of repeaters of Least developed countries in 2007 to that in 2013?
Offer a very short reply. 1.15. What is the ratio of the % of repeaters in China in 2007 to that in 2013?
Provide a succinct answer. 3.53. What is the ratio of the % of repeaters of Cote d'Ivoire in 2007 to that in 2013?
Offer a very short reply. 0.6. What is the ratio of the % of repeaters in Lebanon in 2007 to that in 2013?
Make the answer very short. 1.02. What is the ratio of the % of repeaters of Least developed countries in 2008 to that in 2009?
Your response must be concise. 1.02. What is the ratio of the % of repeaters of China in 2008 to that in 2009?
Ensure brevity in your answer.  1.53. What is the ratio of the % of repeaters in Cote d'Ivoire in 2008 to that in 2009?
Your response must be concise. 0.72. What is the ratio of the % of repeaters in Lebanon in 2008 to that in 2009?
Your response must be concise. 1.01. What is the ratio of the % of repeaters in Least developed countries in 2008 to that in 2011?
Provide a succinct answer. 1.09. What is the ratio of the % of repeaters of China in 2008 to that in 2011?
Your answer should be compact. 1.87. What is the ratio of the % of repeaters of Cote d'Ivoire in 2008 to that in 2011?
Your response must be concise. 0.64. What is the ratio of the % of repeaters in Lebanon in 2008 to that in 2011?
Your response must be concise. 0.95. What is the ratio of the % of repeaters in Least developed countries in 2008 to that in 2012?
Offer a terse response. 1.15. What is the ratio of the % of repeaters in China in 2008 to that in 2012?
Provide a short and direct response. 2.36. What is the ratio of the % of repeaters in Cote d'Ivoire in 2008 to that in 2012?
Provide a succinct answer. 0.64. What is the ratio of the % of repeaters in Lebanon in 2008 to that in 2012?
Your answer should be very brief. 1.04. What is the ratio of the % of repeaters in Least developed countries in 2008 to that in 2013?
Provide a short and direct response. 1.06. What is the ratio of the % of repeaters in China in 2008 to that in 2013?
Your answer should be very brief. 3.41. What is the ratio of the % of repeaters of Cote d'Ivoire in 2008 to that in 2013?
Give a very brief answer. 0.61. What is the ratio of the % of repeaters of Lebanon in 2008 to that in 2013?
Ensure brevity in your answer.  1. What is the ratio of the % of repeaters in Least developed countries in 2009 to that in 2011?
Give a very brief answer. 1.07. What is the ratio of the % of repeaters in China in 2009 to that in 2011?
Provide a short and direct response. 1.22. What is the ratio of the % of repeaters in Cote d'Ivoire in 2009 to that in 2011?
Provide a succinct answer. 0.89. What is the ratio of the % of repeaters in Lebanon in 2009 to that in 2011?
Give a very brief answer. 0.94. What is the ratio of the % of repeaters in Least developed countries in 2009 to that in 2012?
Your response must be concise. 1.13. What is the ratio of the % of repeaters in China in 2009 to that in 2012?
Offer a terse response. 1.54. What is the ratio of the % of repeaters of Cote d'Ivoire in 2009 to that in 2012?
Your answer should be very brief. 0.89. What is the ratio of the % of repeaters of Lebanon in 2009 to that in 2012?
Give a very brief answer. 1.03. What is the ratio of the % of repeaters of Least developed countries in 2009 to that in 2013?
Your answer should be very brief. 1.04. What is the ratio of the % of repeaters of China in 2009 to that in 2013?
Your answer should be compact. 2.23. What is the ratio of the % of repeaters in Cote d'Ivoire in 2009 to that in 2013?
Your answer should be very brief. 0.85. What is the ratio of the % of repeaters of Least developed countries in 2011 to that in 2012?
Provide a short and direct response. 1.05. What is the ratio of the % of repeaters in China in 2011 to that in 2012?
Make the answer very short. 1.26. What is the ratio of the % of repeaters of Cote d'Ivoire in 2011 to that in 2012?
Make the answer very short. 0.99. What is the ratio of the % of repeaters in Lebanon in 2011 to that in 2012?
Offer a very short reply. 1.1. What is the ratio of the % of repeaters in Least developed countries in 2011 to that in 2013?
Your response must be concise. 0.97. What is the ratio of the % of repeaters in China in 2011 to that in 2013?
Keep it short and to the point. 1.82. What is the ratio of the % of repeaters in Cote d'Ivoire in 2011 to that in 2013?
Give a very brief answer. 0.95. What is the ratio of the % of repeaters in Lebanon in 2011 to that in 2013?
Give a very brief answer. 1.05. What is the ratio of the % of repeaters in Least developed countries in 2012 to that in 2013?
Your answer should be very brief. 0.92. What is the ratio of the % of repeaters in China in 2012 to that in 2013?
Provide a short and direct response. 1.45. What is the ratio of the % of repeaters in Cote d'Ivoire in 2012 to that in 2013?
Offer a very short reply. 0.95. What is the ratio of the % of repeaters of Lebanon in 2012 to that in 2013?
Offer a very short reply. 0.96. What is the difference between the highest and the second highest % of repeaters in Least developed countries?
Offer a terse response. 0.01. What is the difference between the highest and the second highest % of repeaters of China?
Give a very brief answer. 0.01. What is the difference between the highest and the second highest % of repeaters of Cote d'Ivoire?
Offer a very short reply. 0.85. What is the difference between the highest and the second highest % of repeaters of Lebanon?
Make the answer very short. 0.19. What is the difference between the highest and the lowest % of repeaters of Least developed countries?
Make the answer very short. 1.85. What is the difference between the highest and the lowest % of repeaters of China?
Your answer should be compact. 0.28. What is the difference between the highest and the lowest % of repeaters of Cote d'Ivoire?
Provide a succinct answer. 7.35. What is the difference between the highest and the lowest % of repeaters of Lebanon?
Offer a terse response. 0.93. 